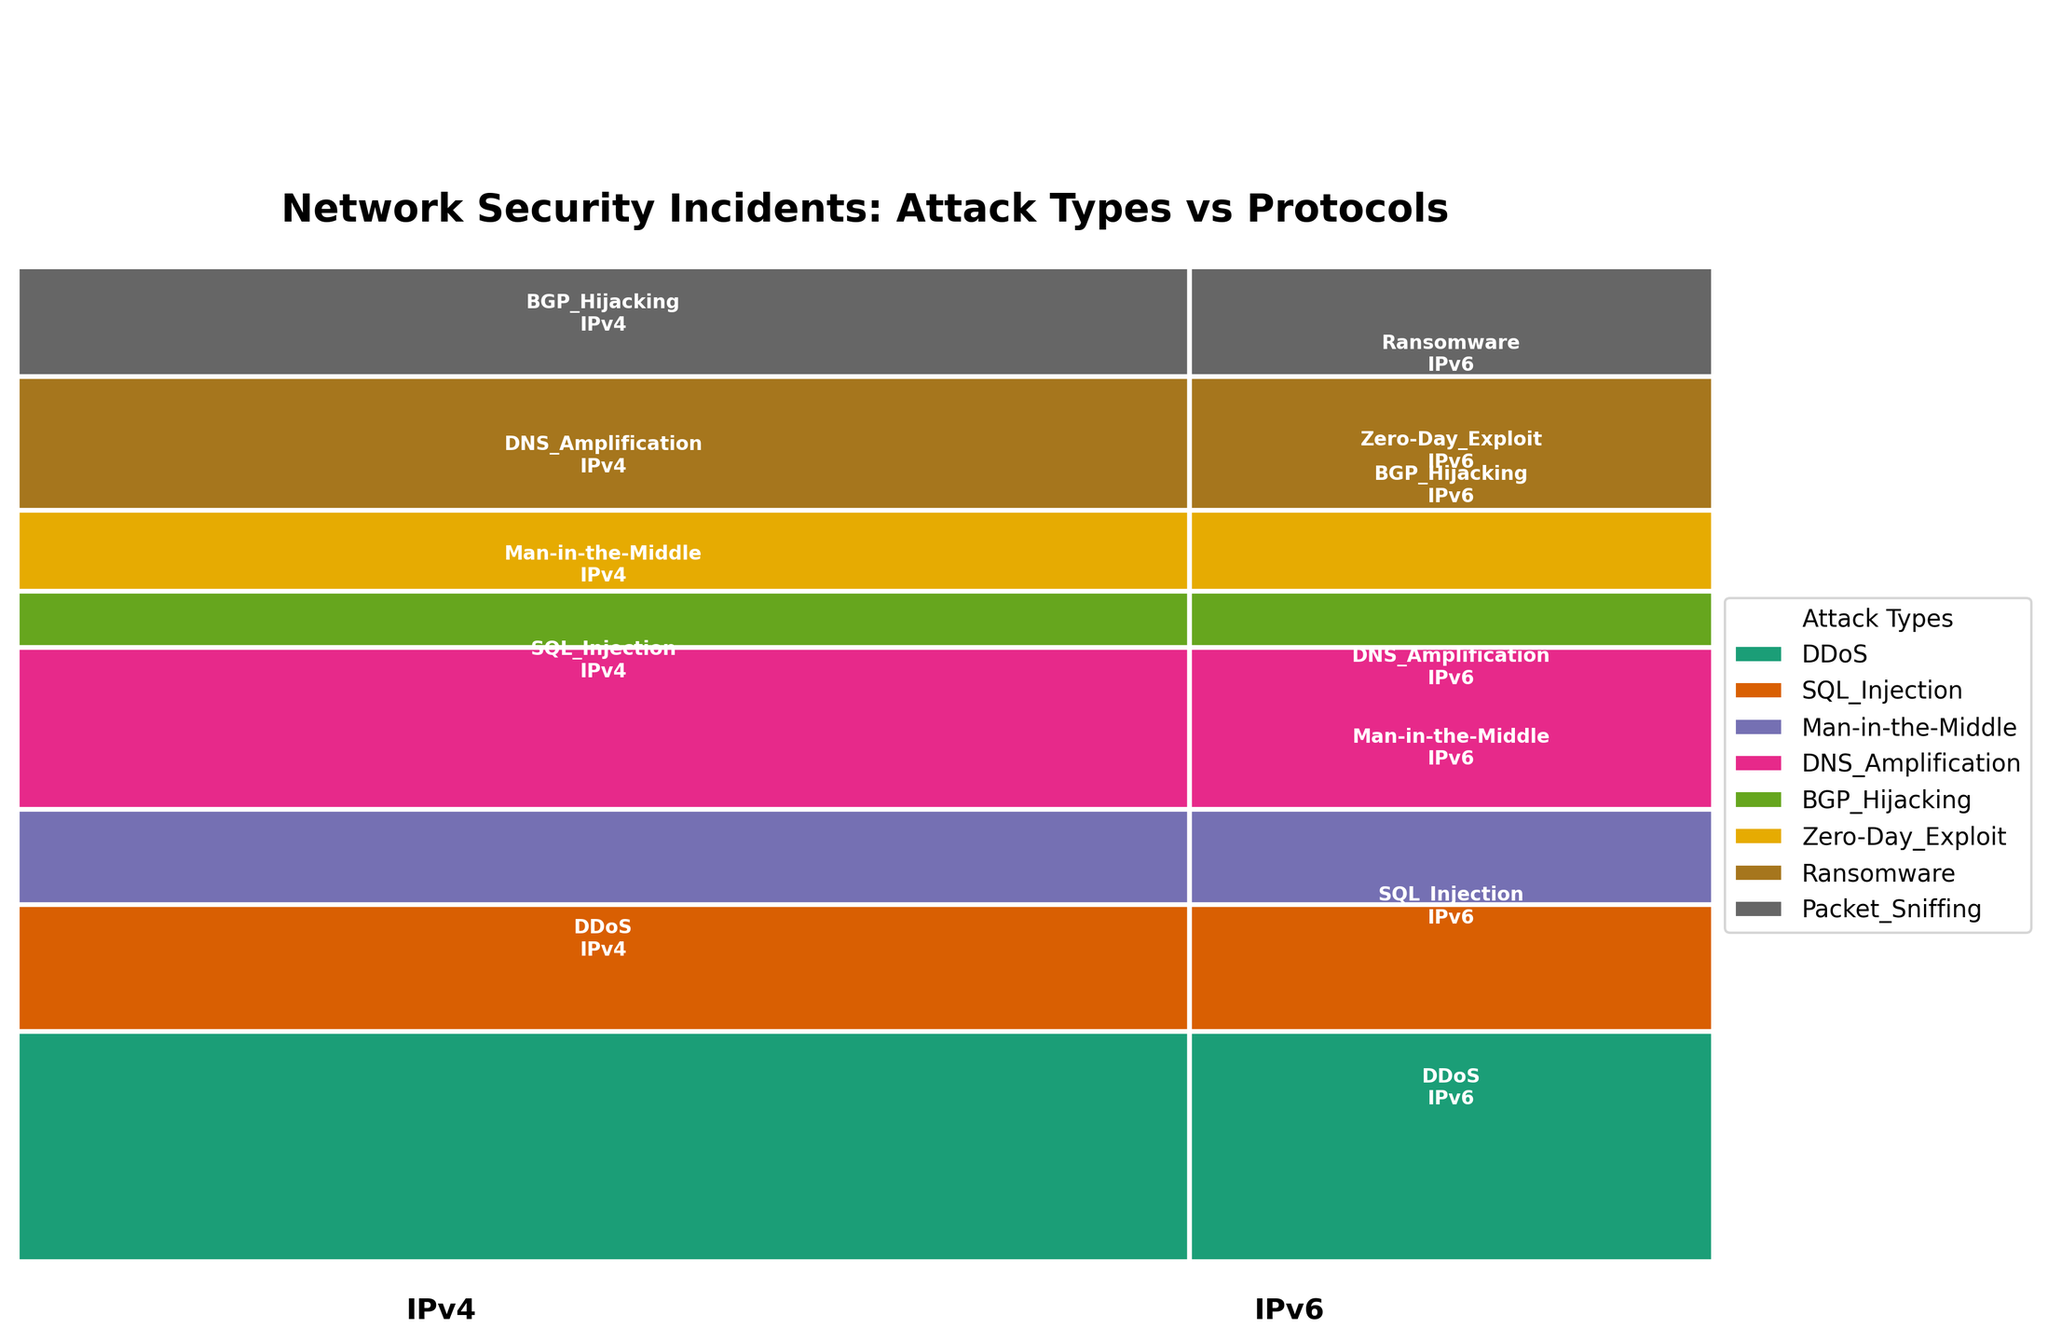Which attack type has the highest number of incidents for IPv4? Look at the height of the rectangles for each attack type under the IPv4 section. The DDoS attack type has the highest vertical extent.
Answer: DDoS Which protocol has more total security incidents: IPv4 or IPv6? Sum up the widths of rectangles belonging to IPv4 and IPv6. The total width for IPv4 is greater than that for IPv6.
Answer: IPv4 What is the total number of incidents for Man-in-the-Middle attacks across both protocols? Sum the counts for Man-in-the-Middle attacks for both protocols: 63 (IPv4) + 29 (IPv6)
Answer: 92 Which attack type has the smallest proportion of incidents in IPv6? Look for the smallest vertical height in the IPv6 section. BGP Hijacking has the smallest height.
Answer: BGP Hijacking Compare the proportions of DNS Amplification incidents between IPv4 and IPv6. Notice the height difference for DNS Amplification in both sections. The proportion for IPv4 is larger than that for IPv6.
Answer: IPv4 has a larger proportion For which attack types does IPv6 have more than half the number of incidents that IPv4 has? Compare counts for each type, checking if the IPv6 count is greater than half of the IPv4 count. Only for DDoS (78 > 145/2 = 72.5) and Zero-Day Exploit (22 > 56/2 = 28) does this hold.
Answer: DDoS and Zero-Day Exploit What proportion of total network security incidents are DDoS attacks? Sum the counts for DDoS (145 + 78), divide by the total count, then multiply by 100. (223 / 961) * 100
Answer: 23.2% Which attack type shows a greater decrease in incidents when comparing IPv4 to IPv6: SQL Injection or Ransomware? Subtract the incidents for IPv6 from IPv4 for both types, and compare the differences. SQL Injection: 92 - 31 = 61, Ransomware: 89 - 41 = 48.
Answer: SQL Injection Which attack type has a nearly equal number of incidents for IPv4 and IPv6? Identify the attack type where the heights for both protocols are closest. Packet Sniffing has 71 (IPv4) and 33 (IPv6), which are relatively close.
Answer: Packet Sniffing 